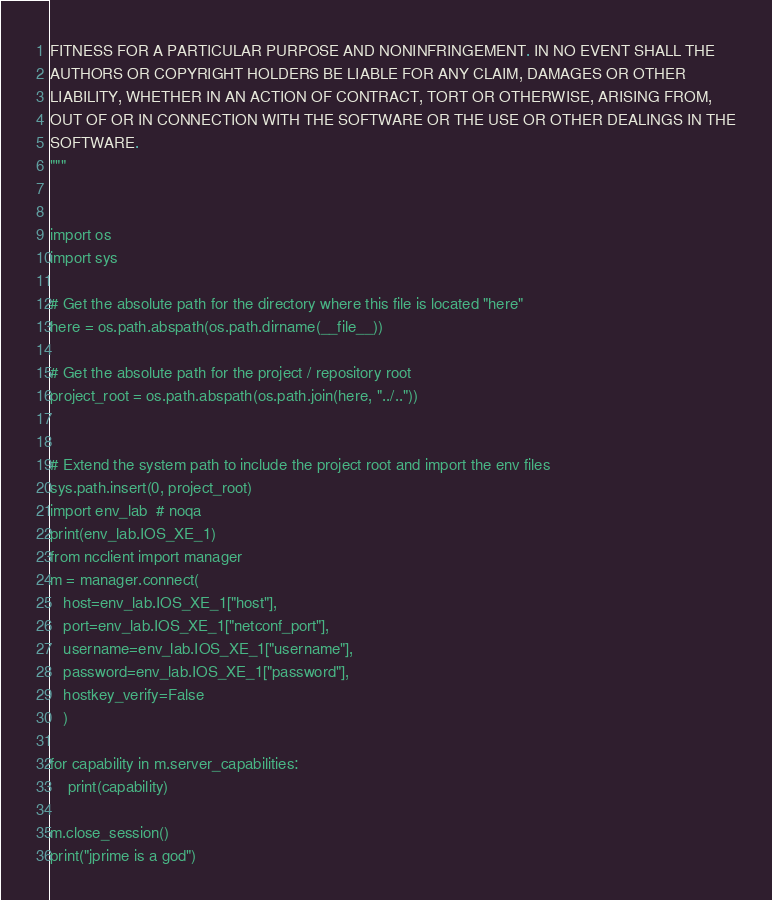Convert code to text. <code><loc_0><loc_0><loc_500><loc_500><_Python_>FITNESS FOR A PARTICULAR PURPOSE AND NONINFRINGEMENT. IN NO EVENT SHALL THE
AUTHORS OR COPYRIGHT HOLDERS BE LIABLE FOR ANY CLAIM, DAMAGES OR OTHER
LIABILITY, WHETHER IN AN ACTION OF CONTRACT, TORT OR OTHERWISE, ARISING FROM,
OUT OF OR IN CONNECTION WITH THE SOFTWARE OR THE USE OR OTHER DEALINGS IN THE
SOFTWARE.
"""


import os
import sys

# Get the absolute path for the directory where this file is located "here"
here = os.path.abspath(os.path.dirname(__file__))

# Get the absolute path for the project / repository root
project_root = os.path.abspath(os.path.join(here, "../.."))


# Extend the system path to include the project root and import the env files
sys.path.insert(0, project_root)
import env_lab  # noqa
print(env_lab.IOS_XE_1)
from ncclient import manager
m = manager.connect(
   host=env_lab.IOS_XE_1["host"],
   port=env_lab.IOS_XE_1["netconf_port"],
   username=env_lab.IOS_XE_1["username"],
   password=env_lab.IOS_XE_1["password"],
   hostkey_verify=False
   )

for capability in m.server_capabilities:
	print(capability)

m.close_session()
print("jprime is a god")
</code> 